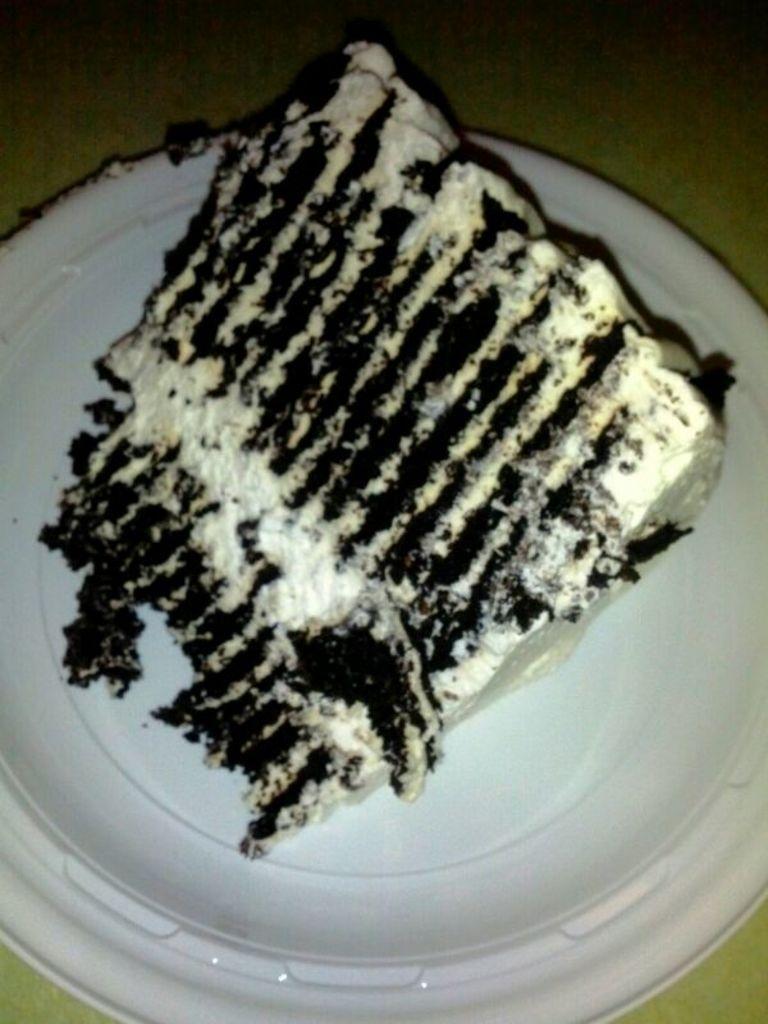Please provide a concise description of this image. In this picture I can see there is food in a plate. 